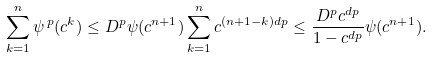<formula> <loc_0><loc_0><loc_500><loc_500>\sum _ { k = 1 } ^ { n } \psi ^ { \, p } ( c ^ { k } ) \leq D ^ { p } \psi ( c ^ { n + 1 } ) \sum _ { k = 1 } ^ { n } c ^ { ( n + 1 - k ) d p } \leq \frac { D ^ { p } c ^ { d p } } { 1 - c ^ { d p } } \psi ( c ^ { n + 1 } ) .</formula> 